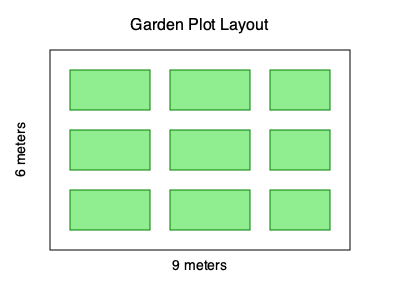In a rectangular garden plot measuring 9 meters by 6 meters, you want to maximize the number of raised beds while maintaining 1-meter wide pathways between beds and around the perimeter. Each raised bed measures 2 meters by 1 meter. How many raised beds can be accommodated in this layout? To solve this problem, let's follow these steps:

1. Calculate the available space for beds:
   - Width: 9m - 2m (perimeter paths) = 7m
   - Length: 6m - 2m (perimeter paths) = 4m

2. Determine how many beds fit along the width:
   - Each bed is 2m wide
   - Path between beds is 1m
   - 7m ÷ (2m + 1m) = 2 beds with 1m left over

3. Determine how many beds fit along the length:
   - Each bed is 1m long
   - 4m ÷ 1m = 4 beds

4. Calculate the total number of beds:
   - Beds along width × Beds along length = 2 × 4 = 8 beds

5. Account for the extra 1m width:
   - We can fit one more column of beds, but they'll be shorter (1.5m instead of 2m)
   - 3 additional beds can fit in this column

Therefore, the total number of raised beds that can be accommodated is:
$$ 8 \text{ (full-size beds)} + 3 \text{ (shorter beds)} = 11 \text{ beds} $$
Answer: 11 beds 